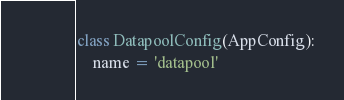Convert code to text. <code><loc_0><loc_0><loc_500><loc_500><_Python_>class DatapoolConfig(AppConfig):
    name = 'datapool'
</code> 